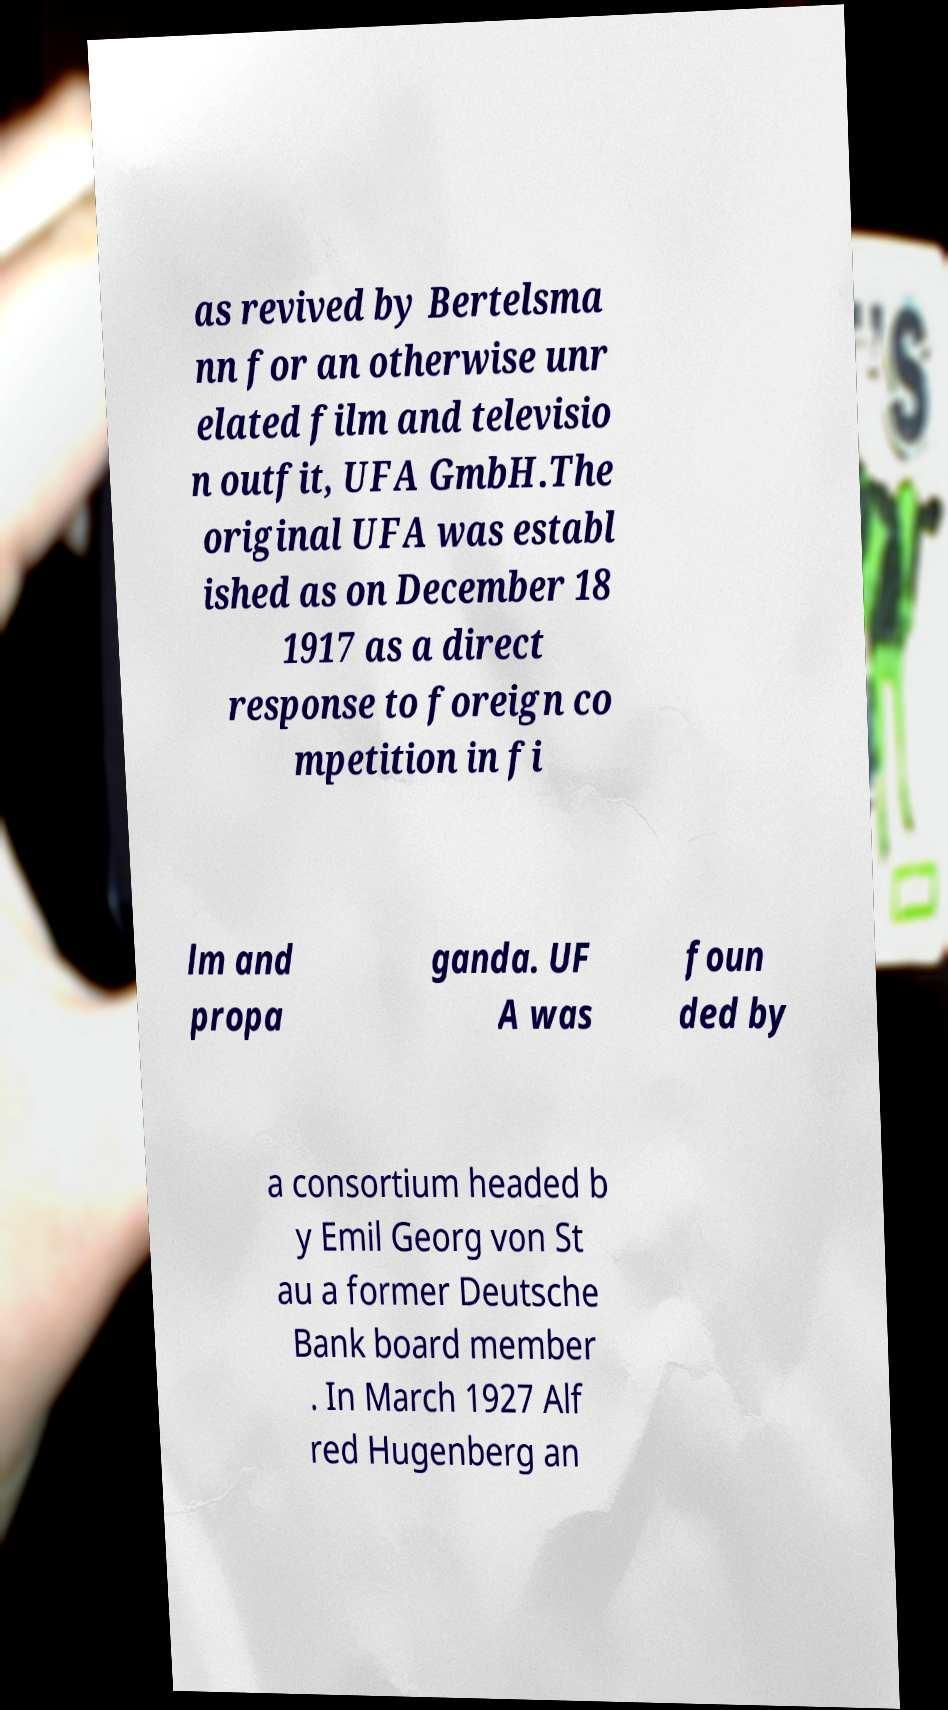Can you accurately transcribe the text from the provided image for me? as revived by Bertelsma nn for an otherwise unr elated film and televisio n outfit, UFA GmbH.The original UFA was establ ished as on December 18 1917 as a direct response to foreign co mpetition in fi lm and propa ganda. UF A was foun ded by a consortium headed b y Emil Georg von St au a former Deutsche Bank board member . In March 1927 Alf red Hugenberg an 